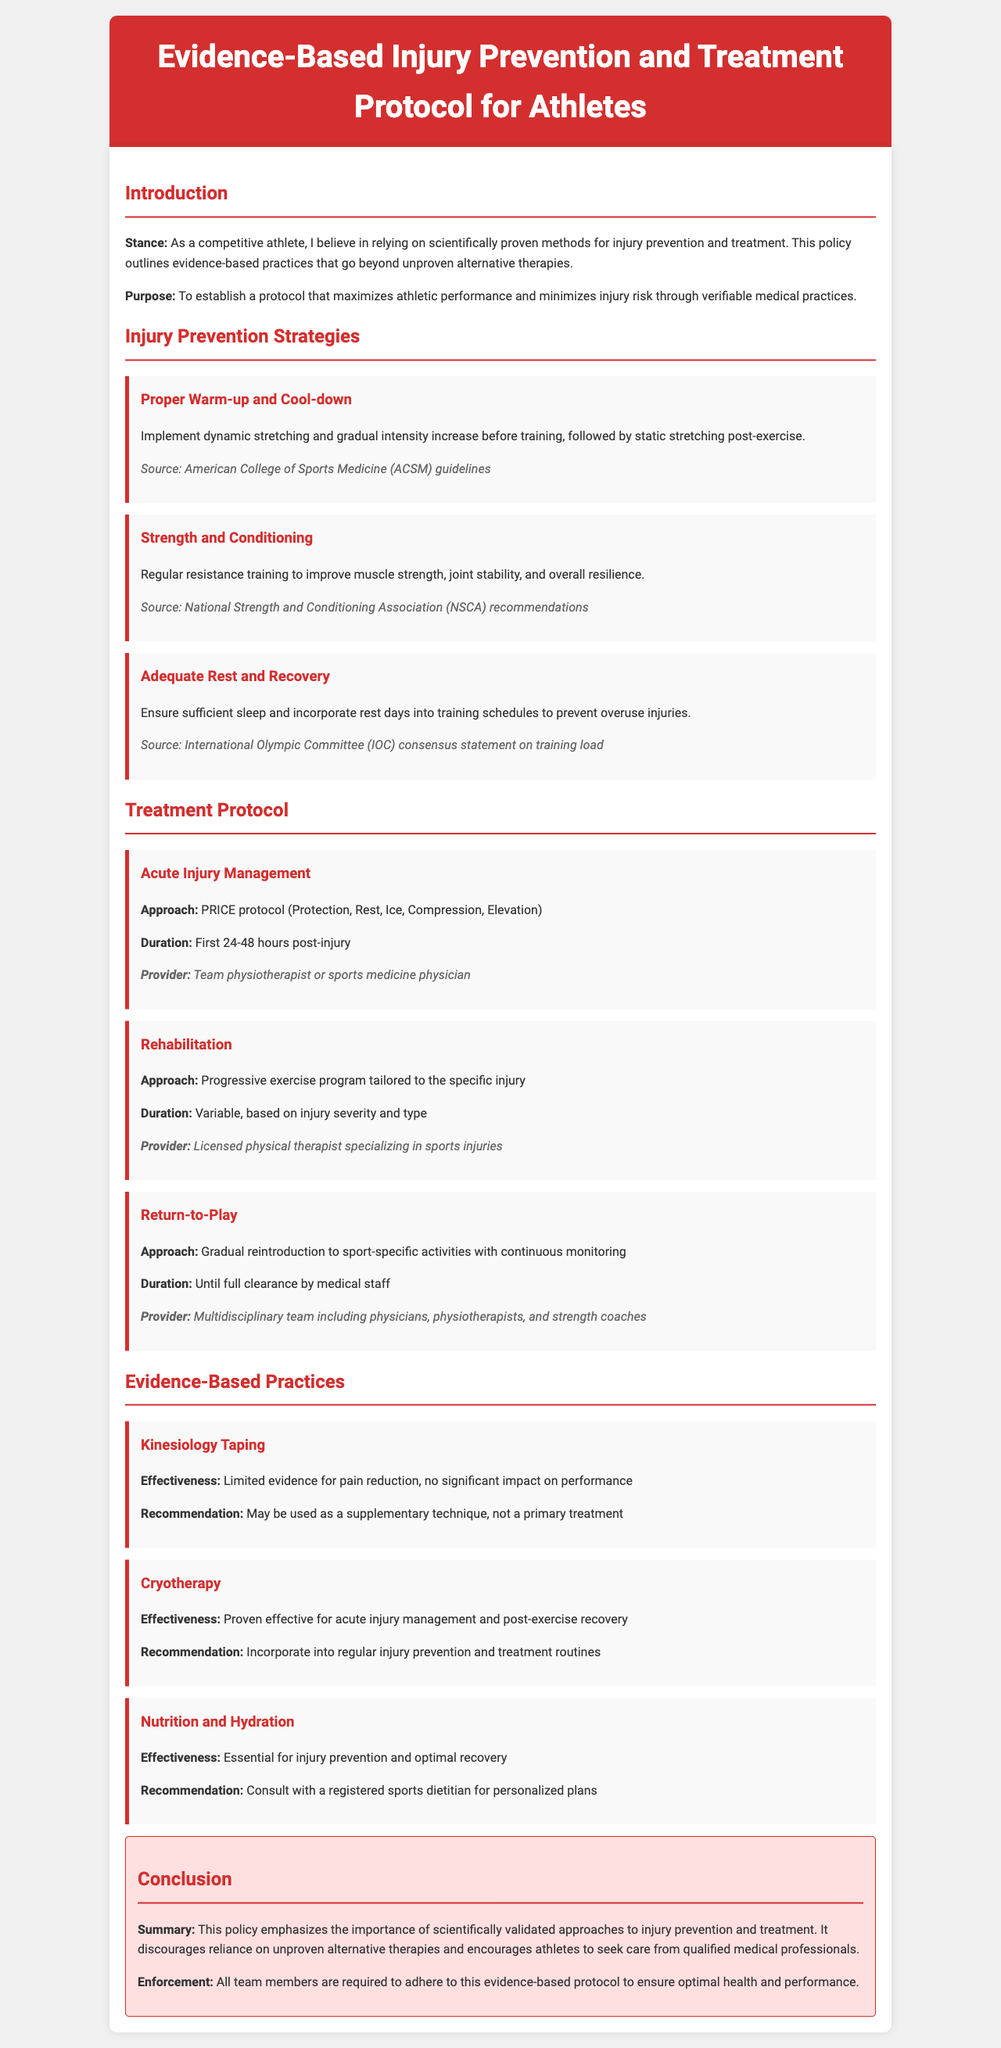what is the purpose of the policy? The purpose of the policy is to establish a protocol that maximizes athletic performance and minimizes injury risk through verifiable medical practices.
Answer: to establish a protocol that maximizes athletic performance and minimizes injury risk through verifiable medical practices which organization provides guidelines for proper warm-up and cool-down? The document states that the American College of Sports Medicine provides guidelines for proper warm-up and cool-down.
Answer: American College of Sports Medicine what is the first step in the acute injury management protocol? The first step in the acute injury management protocol is Protection as outlined in the PRICE protocol.
Answer: Protection how long should sufficient rest and recovery be ensured? The document implies that adequate rest and recovery refer to incorporating rest days into training schedules, the exact duration isn’t specified.
Answer: not specified what is the recommendation for kinesiology taping? The document recommends that kinesiology taping may be used as a supplementary technique, not a primary treatment.
Answer: May be used as a supplementary technique, not a primary treatment which approach is recommended for return-to-play? The approach for return-to-play is gradual reintroduction to sport-specific activities with continuous monitoring.
Answer: gradual reintroduction to sport-specific activities with continuous monitoring how often should strength and conditioning be practiced? The document does not specify an exact frequency for strength and conditioning but emphasizes regular resistance training.
Answer: regular resistance training what does the document emphasize regarding alternative therapies? The document emphasizes the importance of scientifically validated approaches to injury prevention and treatment and discourages reliance on unproven alternative therapies.
Answer: discourages reliance on unproven alternative therapies 